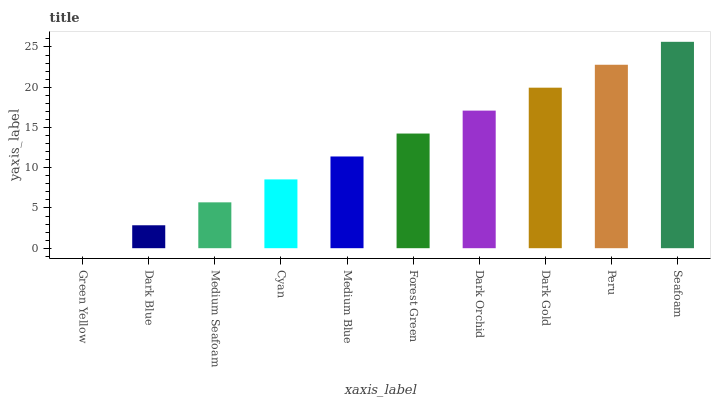Is Green Yellow the minimum?
Answer yes or no. Yes. Is Seafoam the maximum?
Answer yes or no. Yes. Is Dark Blue the minimum?
Answer yes or no. No. Is Dark Blue the maximum?
Answer yes or no. No. Is Dark Blue greater than Green Yellow?
Answer yes or no. Yes. Is Green Yellow less than Dark Blue?
Answer yes or no. Yes. Is Green Yellow greater than Dark Blue?
Answer yes or no. No. Is Dark Blue less than Green Yellow?
Answer yes or no. No. Is Forest Green the high median?
Answer yes or no. Yes. Is Medium Blue the low median?
Answer yes or no. Yes. Is Dark Blue the high median?
Answer yes or no. No. Is Forest Green the low median?
Answer yes or no. No. 